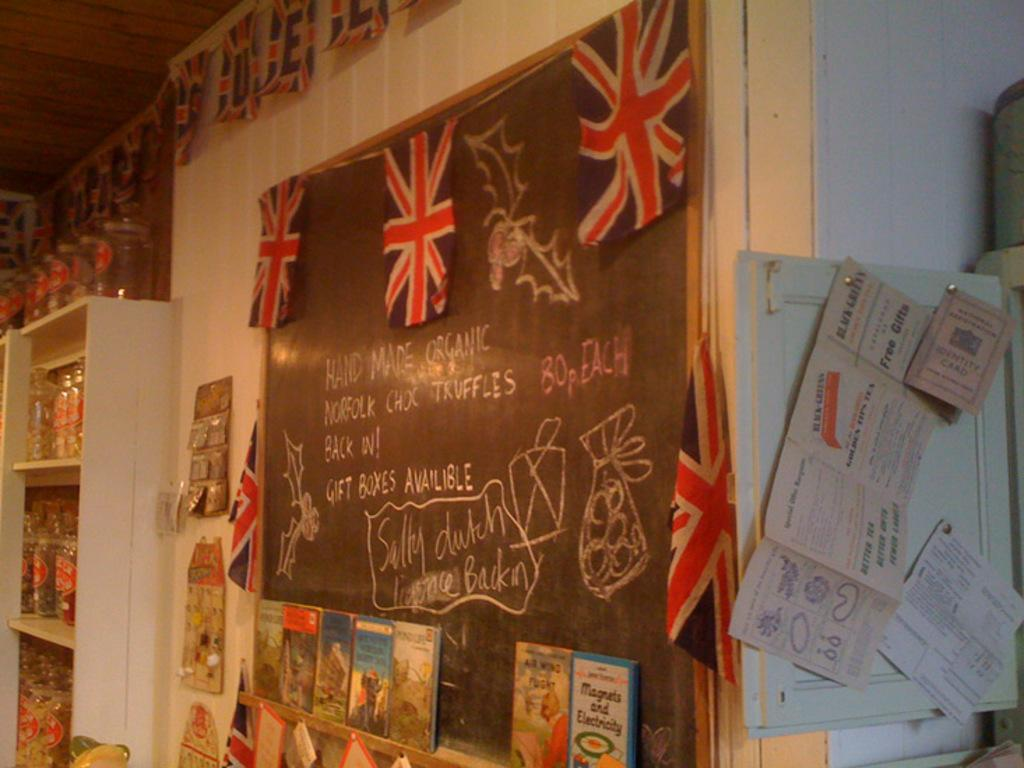<image>
Describe the image concisely. a board that says 'silly dutch' on it 